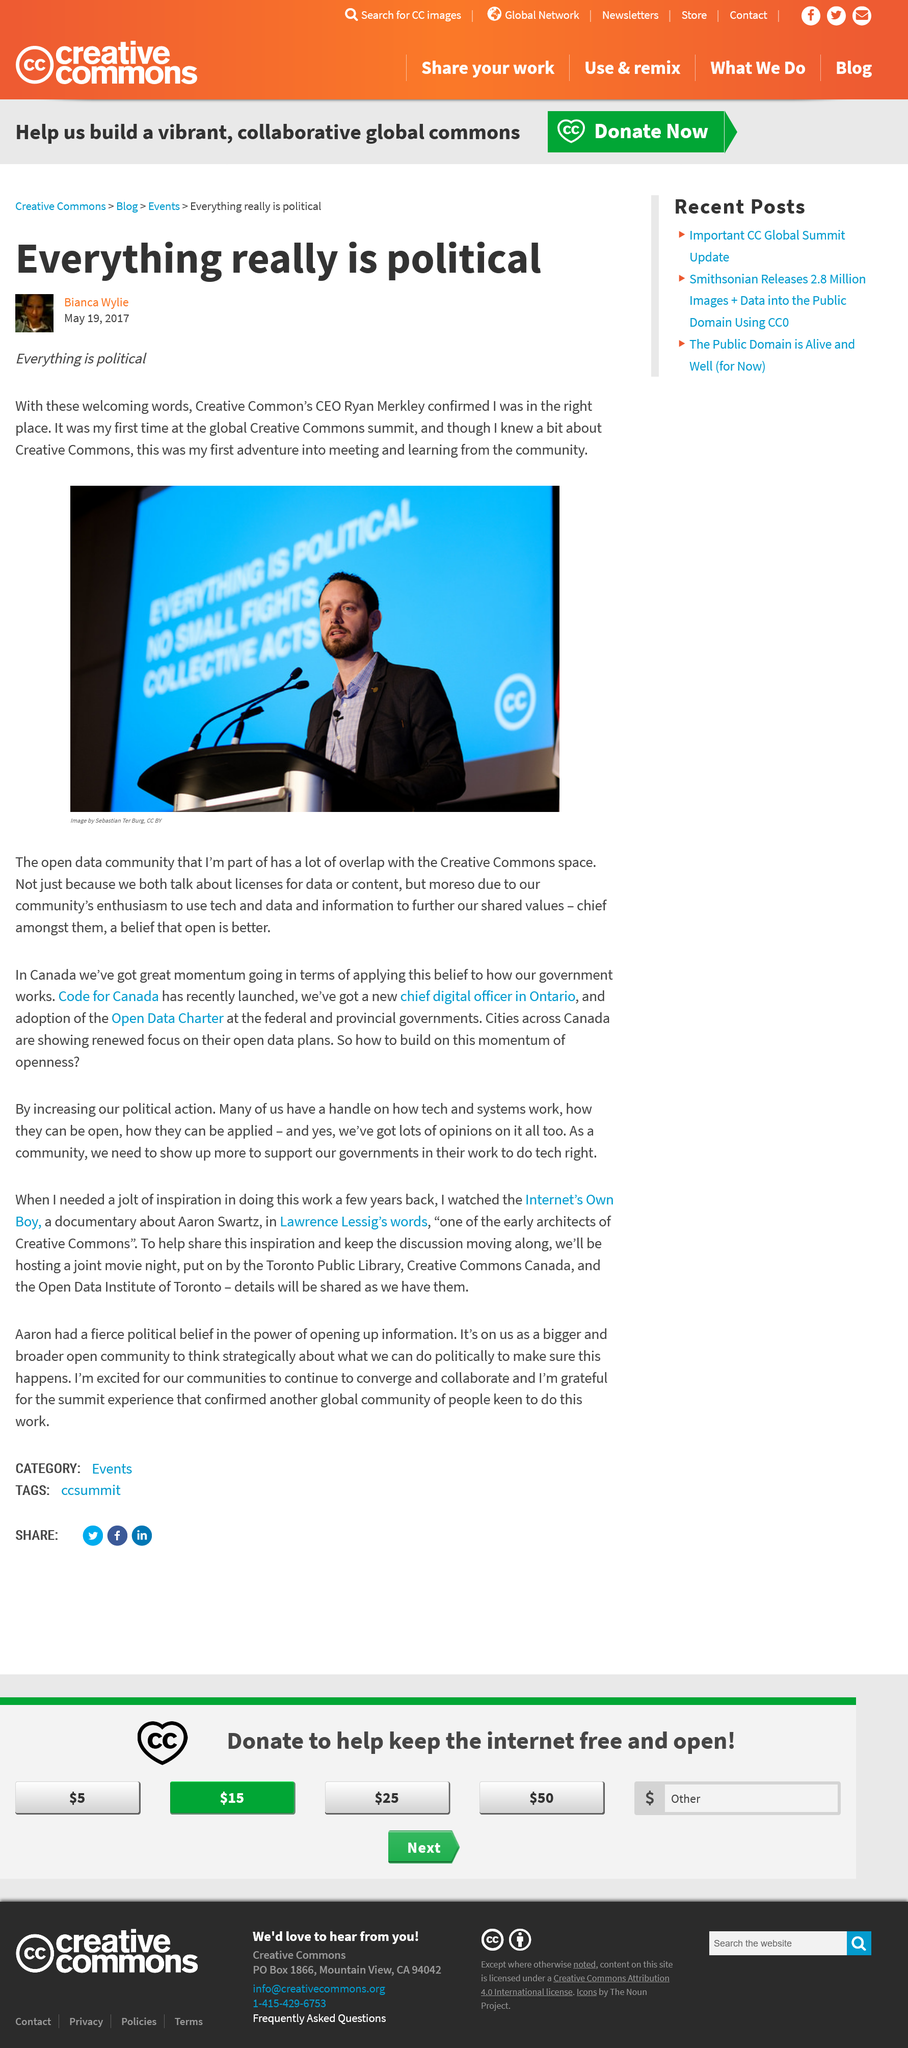Point out several critical features in this image. The CEO of Creative Common is Ryan Merkley. Bianca Wylie has attended the global Creative Commons summit only once. The man depicted in the image is Ryan Merkley. 